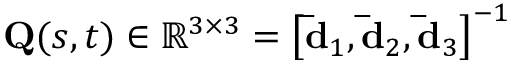Convert formula to latex. <formula><loc_0><loc_0><loc_500><loc_500>Q ( s , t ) \in \mathbb { R } ^ { 3 \times 3 } = \left [ \bar { d } _ { 1 } , \bar { d } _ { 2 } , \bar { d } _ { 3 } \right ] ^ { - 1 }</formula> 